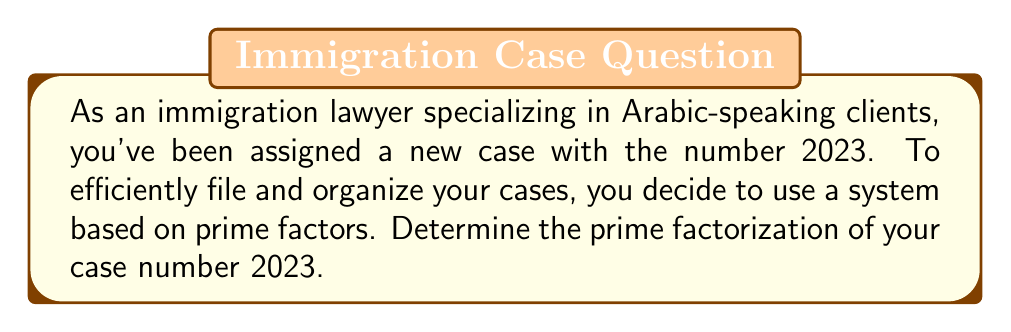Solve this math problem. To find the prime factorization of 2023, we'll use the following steps:

1) First, let's check if 2023 is divisible by the smallest prime number, 2:
   $2023 \div 2 = 1011.5$ (not an integer)

2) Since it's not divisible by 2, let's try the next prime number, 3:
   $2023 \div 3 = 674.33...$ (not an integer)

3) We can continue this process with the next few prime numbers (5, 7, 11, etc.), but let's use a more efficient method. We only need to check up to the square root of 2023, which is approximately 44.98.

4) The next prime to check is 43:
   $2023 \div 43 = 47$ (an integer)

5) We've found our first factor. Now let's factorize the quotient, 47:
   47 is a prime number itself.

Therefore, the prime factorization of 2023 is:

$$2023 = 43 \times 47$$

Both 43 and 47 are prime numbers, so this is the complete prime factorization.
Answer: The prime factorization of 2023 is $43 \times 47$. 